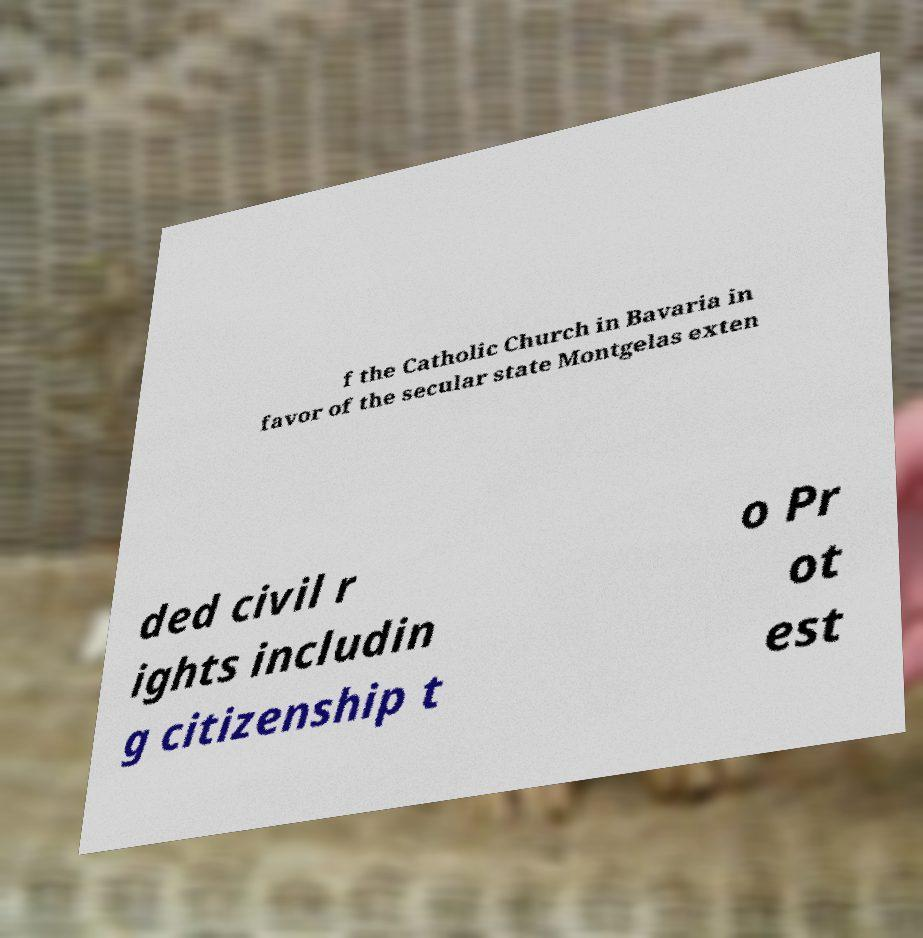Can you read and provide the text displayed in the image?This photo seems to have some interesting text. Can you extract and type it out for me? f the Catholic Church in Bavaria in favor of the secular state Montgelas exten ded civil r ights includin g citizenship t o Pr ot est 